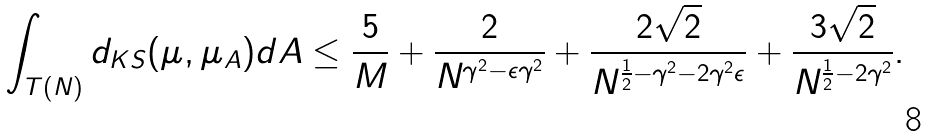<formula> <loc_0><loc_0><loc_500><loc_500>\int _ { T ( N ) } d _ { K S } ( \mu , \mu _ { A } ) d A \leq \frac { 5 } { M } + \frac { 2 } { N ^ { \gamma ^ { 2 } - \epsilon \gamma ^ { 2 } } } + \frac { 2 \sqrt { 2 } } { N ^ { \frac { 1 } { 2 } - \gamma ^ { 2 } - 2 \gamma ^ { 2 } \epsilon } } + \frac { 3 \sqrt { 2 } } { N ^ { \frac { 1 } { 2 } - 2 \gamma ^ { 2 } } } .</formula> 